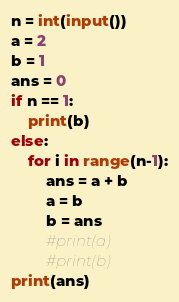Convert code to text. <code><loc_0><loc_0><loc_500><loc_500><_Python_>n = int(input())
a = 2
b = 1
ans = 0
if n == 1:
    print(b)
else:
    for i in range(n-1):
        ans = a + b
        a = b
        b = ans
        #print(a)
        #print(b)
print(ans)</code> 